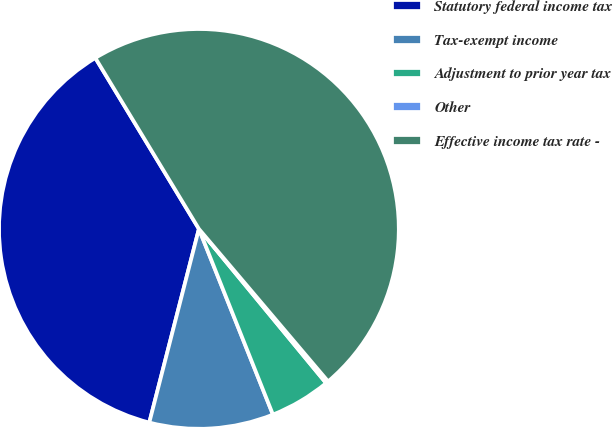Convert chart to OTSL. <chart><loc_0><loc_0><loc_500><loc_500><pie_chart><fcel>Statutory federal income tax<fcel>Tax-exempt income<fcel>Adjustment to prior year tax<fcel>Other<fcel>Effective income tax rate -<nl><fcel>37.34%<fcel>10.03%<fcel>4.94%<fcel>0.21%<fcel>47.48%<nl></chart> 